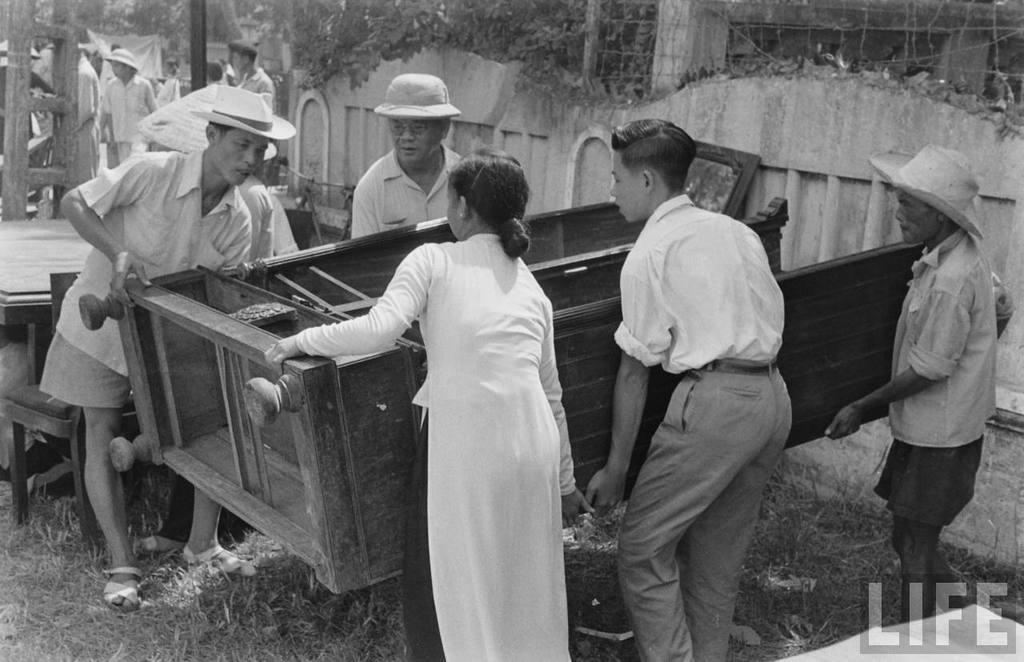Can you describe this image briefly? This is a black and white image. 5 people are holding a wooden furniture. 3 of them are wearing hats. There are other people at the back. Behind them there is a wall, fencing and trees. 